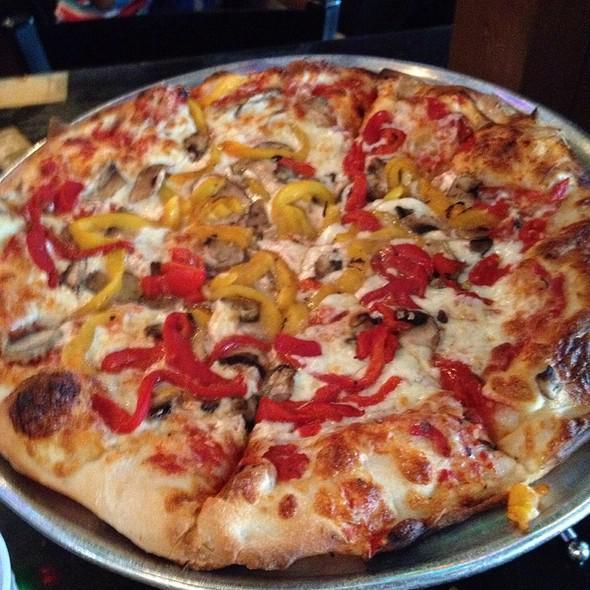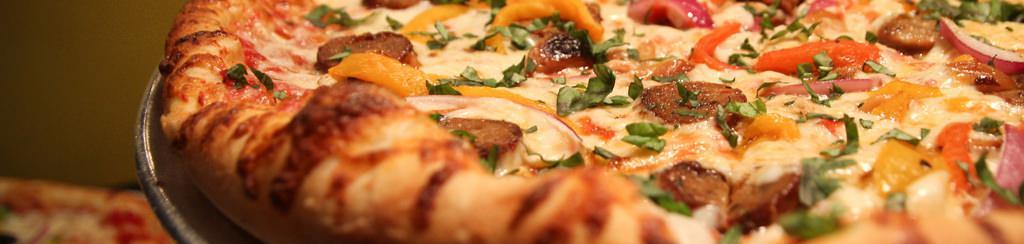The first image is the image on the left, the second image is the image on the right. Assess this claim about the two images: "Part of a round metal tray is visible between at least two slices of pizza in the right image.". Correct or not? Answer yes or no. No. 